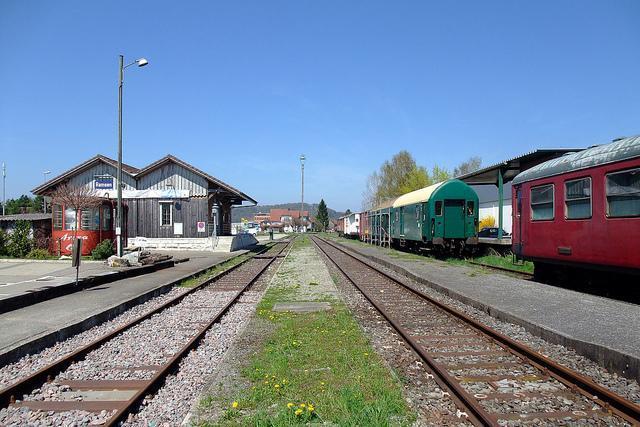How many tracks are seen?
Give a very brief answer. 2. How many trains are in the picture?
Give a very brief answer. 2. How many women are to the right of the signpost?
Give a very brief answer. 0. 